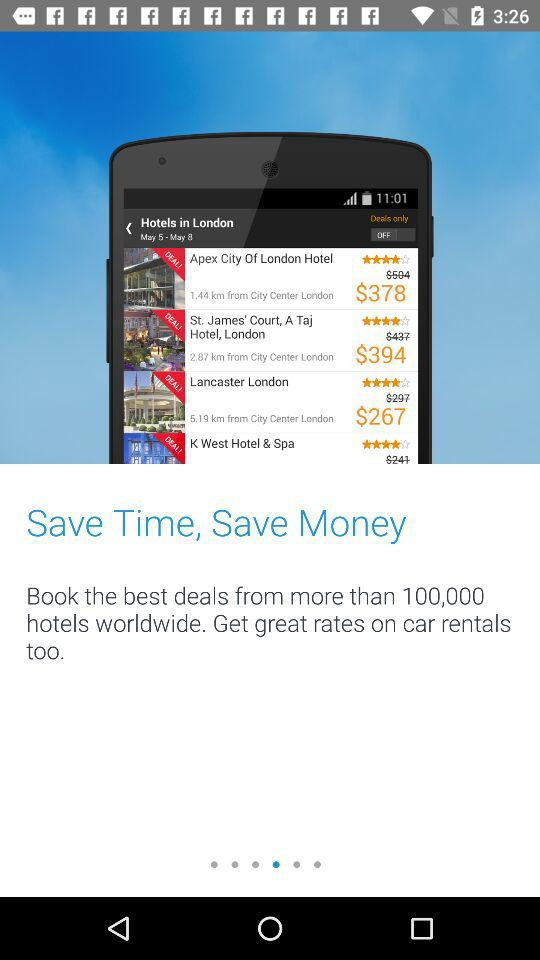What is the rating of the "Apex City of London Hotel"? The rating is 4 stars. 